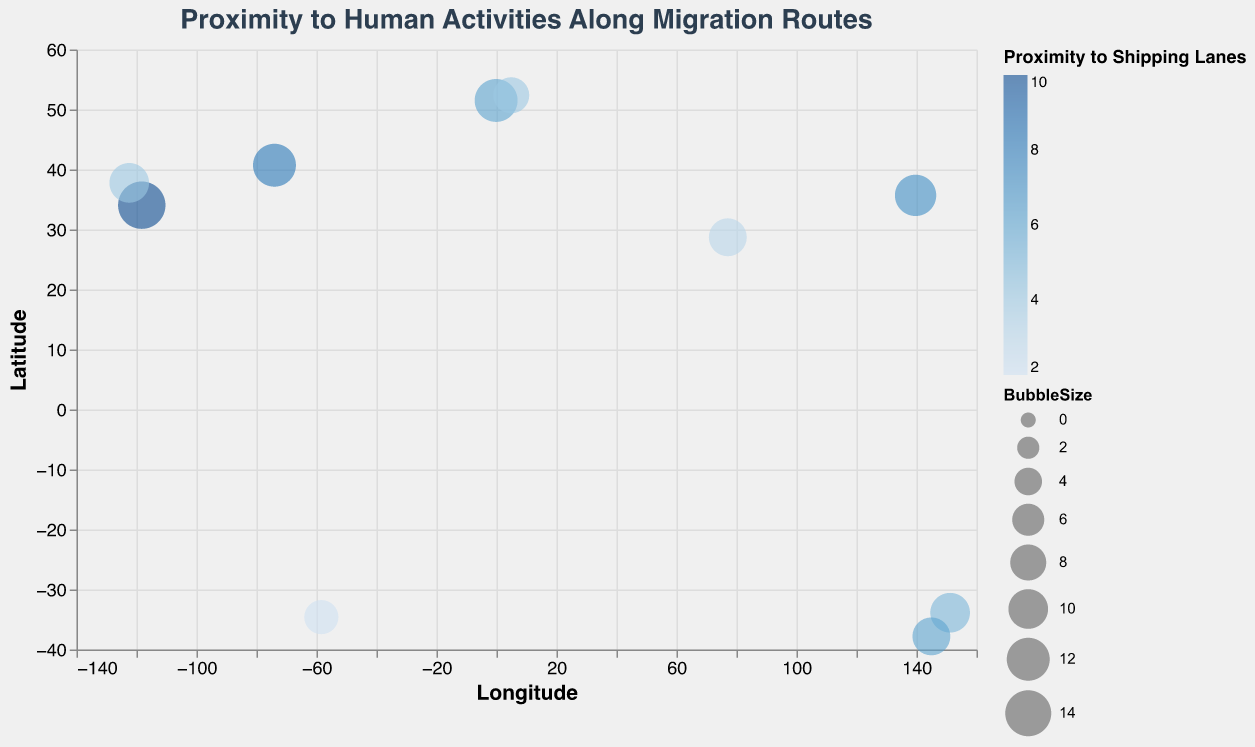What is the title of the chart? The title of the chart is displayed at the top and reads, "Proximity to Human Activities Along Migration Routes".
Answer: "Proximity to Human Activities Along Migration Routes" How many data points are shown in the chart? By counting each bubble in the chart, we find there is a total of 10 data points represented by 10 bubbles.
Answer: 10 Which location has the bubble with the largest size? By comparing the BubbleSize values of all the data points, the largest bubble corresponds to the location at latitude 34.0522 and longitude -118.2437 with a Bubble Size of 15.
Answer: Latitude 34.0522, Longitude -118.2437 What is the pollution level for the location closest to shipping lanes? The data point closest to shipping lanes has a ProximityToShippingLanes value of 10, which corresponds to the location at Latitude 34.0522 and Longitude -118.2437 with a PollutionLevel of 7.
Answer: 7 Which location has the highest pollution level and what is its proximity to shipping lanes? The highest pollution level is found by recognizing the highest PollutionLevel value, which is 9. This corresponds to the location at Latitude 40.7128 and Longitude -74.0060 with a ProximityToShippingLanes value of 8.
Answer: Latitude 40.7128, Longitude -74.0060, Proximity to Shipping Lanes 8 Which data point represents a location with a latitude greater than 30 and longitude less than -100? Scanning through the data points, the one that fits these criteria is at Latitude 34.0522 and Longitude -118.2437, with properties like ProximityToShippingLanes 10 and PollutionLevel 7.
Answer: Latitude 34.0522, Longitude -118.2437 What is the sum of Proximity to Shipping Lanes values for all locations? Adding up the ProximityToShippingLanes values from all data points: 10 + 8 + 4 + 7 + 6 + 3 + 5 + 4 + 2 + 6, we get 55.
Answer: 55 Among the locations with a pollution level of 7, which one is farthest from shipping lanes? Identifying locations with PollutionLevel of 7, which are at Latitude 34.0522/Longitude -118.2437 (ProximityToShippingLanes 10) and Latitude 28.7041/Longitude 77.1025 (ProximityToShippingLanes 3). The farthest is the one with ProximityToShippingLanes value of 10.
Answer: Latitude 34.0522, Longitude -118.2437 What is the range of bubble sizes in the chart? The bubble sizes range from the smallest value to the largest value, which are 7 and 15 respectively.
Answer: 7 to 15 Which location has a PollutionLevel of 4 and how large is its bubble? The location with a PollutionLevel of 4 is at Latitude -33.8688 and Longitude 151.2093. The BubbleSize for this location is 10.
Answer: Latitude -33.8688, Longitude 151.2093, Bubble Size 10 